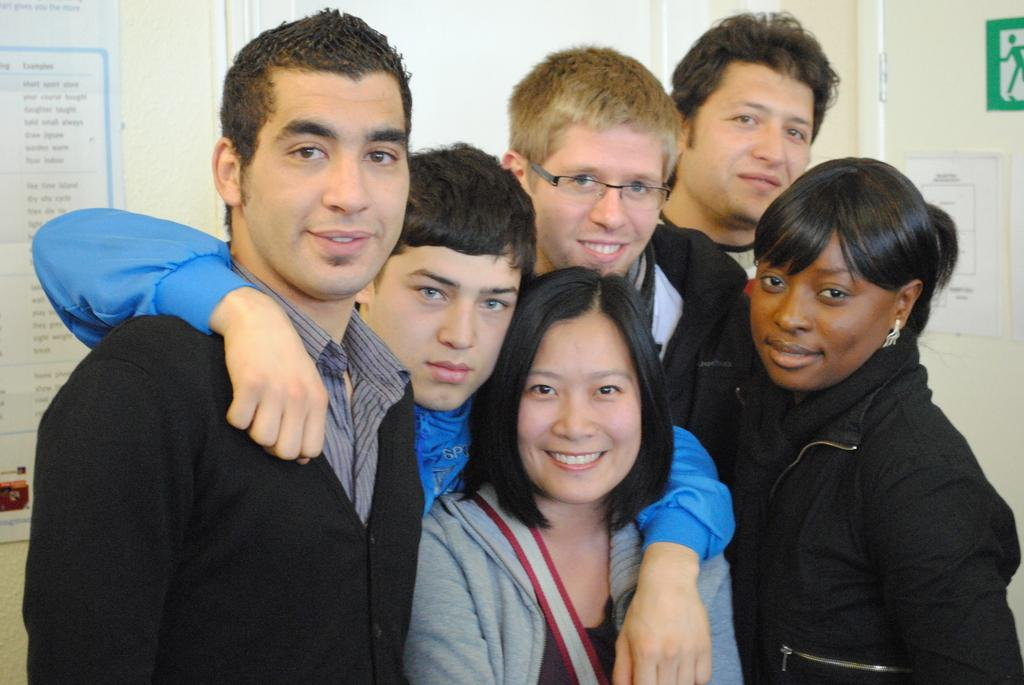What can be seen in the image? There are people standing in the image. What is visible in the background? There is a wall in the background of the image. What object is present in the image? There is a board visible in the image. Where is the door located in the image? There is a door on the right side of the image. What route do the people in the image take to express their regret? There is no mention of a route, people expressing regret, or any behavior in the image. 